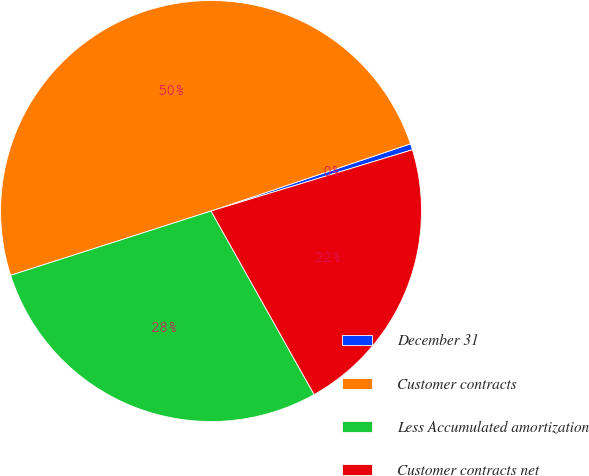Convert chart. <chart><loc_0><loc_0><loc_500><loc_500><pie_chart><fcel>December 31<fcel>Customer contracts<fcel>Less Accumulated amortization<fcel>Customer contracts net<nl><fcel>0.47%<fcel>49.77%<fcel>28.2%<fcel>21.56%<nl></chart> 